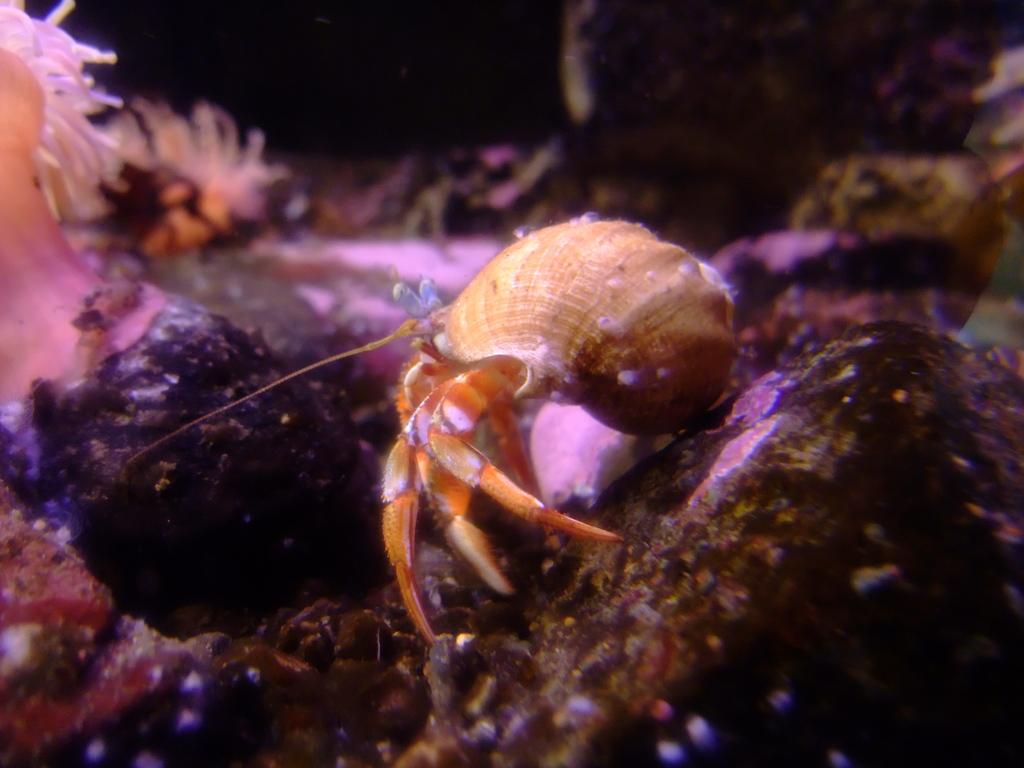What is located in the middle of the image? There are water marines in the middle of the image. What is the color of the background in the image? The background of the image appears to be black. What can be seen at the bottom of the image? There are stones visible at the bottom of the image. How many cacti can be seen in the image? There are no cacti present in the image. What type of wine is being served in the image? There is no wine present in the image. 